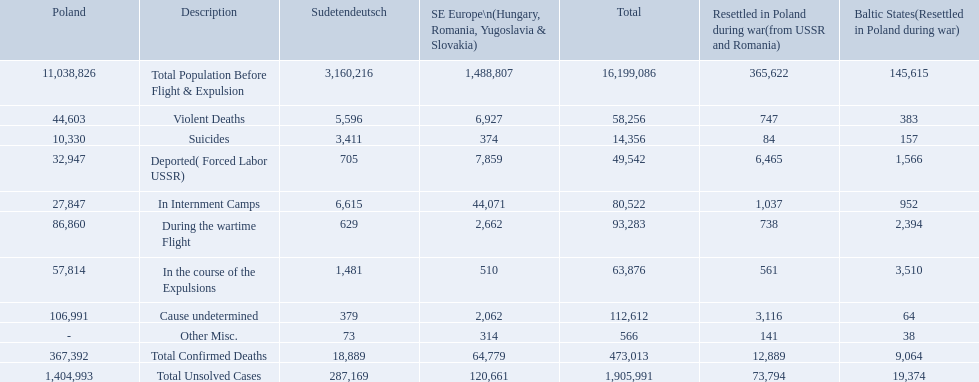How many deaths did the baltic states have in each category? 145,615, 383, 157, 1,566, 952, 2,394, 3,510, 64, 38, 9,064, 19,374. How many cause undetermined deaths did baltic states have? 64. How many other miscellaneous deaths did baltic states have? 38. Which is higher in deaths, cause undetermined or other miscellaneous? Cause undetermined. What were all of the types of deaths? Violent Deaths, Suicides, Deported( Forced Labor USSR), In Internment Camps, During the wartime Flight, In the course of the Expulsions, Cause undetermined, Other Misc. And their totals in the baltic states? 383, 157, 1,566, 952, 2,394, 3,510, 64, 38. Were more deaths in the baltic states caused by undetermined causes or misc.? Cause undetermined. 